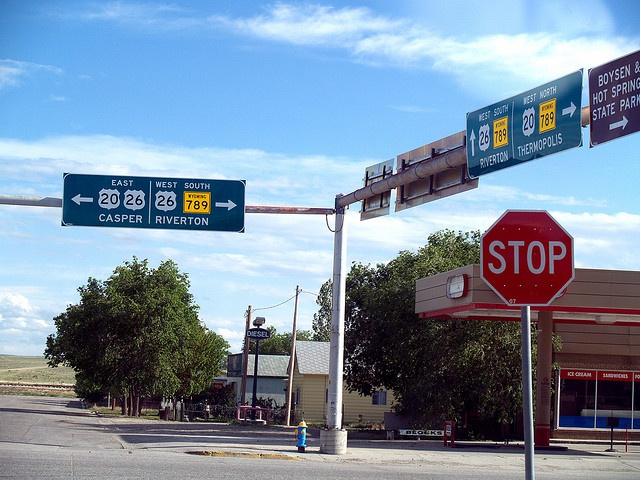Describe the objects in this image and their specific colors. I can see stop sign in gray and maroon tones, bench in gray, black, and darkgray tones, and fire hydrant in gray, blue, black, navy, and lightblue tones in this image. 